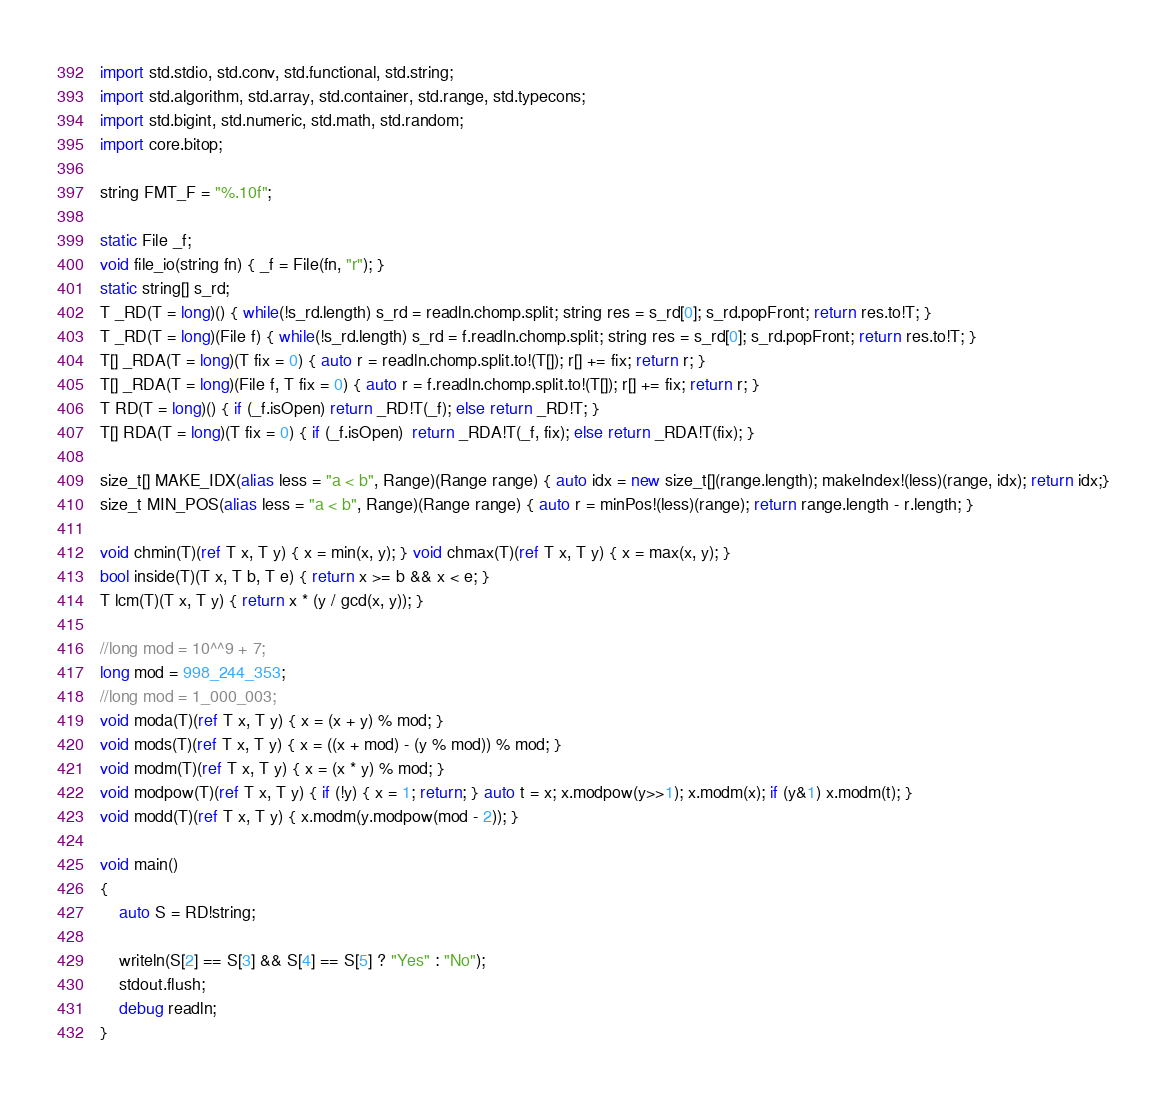Convert code to text. <code><loc_0><loc_0><loc_500><loc_500><_D_>import std.stdio, std.conv, std.functional, std.string;
import std.algorithm, std.array, std.container, std.range, std.typecons;
import std.bigint, std.numeric, std.math, std.random;
import core.bitop;

string FMT_F = "%.10f";

static File _f;
void file_io(string fn) { _f = File(fn, "r"); }
static string[] s_rd;
T _RD(T = long)() { while(!s_rd.length) s_rd = readln.chomp.split; string res = s_rd[0]; s_rd.popFront; return res.to!T; }
T _RD(T = long)(File f) { while(!s_rd.length) s_rd = f.readln.chomp.split; string res = s_rd[0]; s_rd.popFront; return res.to!T; }
T[] _RDA(T = long)(T fix = 0) { auto r = readln.chomp.split.to!(T[]); r[] += fix; return r; }
T[] _RDA(T = long)(File f, T fix = 0) { auto r = f.readln.chomp.split.to!(T[]); r[] += fix; return r; }
T RD(T = long)() { if (_f.isOpen) return _RD!T(_f); else return _RD!T; }
T[] RDA(T = long)(T fix = 0) { if (_f.isOpen)  return _RDA!T(_f, fix); else return _RDA!T(fix); }

size_t[] MAKE_IDX(alias less = "a < b", Range)(Range range) { auto idx = new size_t[](range.length); makeIndex!(less)(range, idx); return idx;}
size_t MIN_POS(alias less = "a < b", Range)(Range range) { auto r = minPos!(less)(range); return range.length - r.length; }

void chmin(T)(ref T x, T y) { x = min(x, y); } void chmax(T)(ref T x, T y) { x = max(x, y); }
bool inside(T)(T x, T b, T e) { return x >= b && x < e; }
T lcm(T)(T x, T y) { return x * (y / gcd(x, y)); }

//long mod = 10^^9 + 7;
long mod = 998_244_353;
//long mod = 1_000_003;
void moda(T)(ref T x, T y) { x = (x + y) % mod; }
void mods(T)(ref T x, T y) { x = ((x + mod) - (y % mod)) % mod; }
void modm(T)(ref T x, T y) { x = (x * y) % mod; }
void modpow(T)(ref T x, T y) { if (!y) { x = 1; return; } auto t = x; x.modpow(y>>1); x.modm(x); if (y&1) x.modm(t); }
void modd(T)(ref T x, T y) { x.modm(y.modpow(mod - 2)); }

void main()
{
	auto S = RD!string;

	writeln(S[2] == S[3] && S[4] == S[5] ? "Yes" : "No");
	stdout.flush;
	debug readln;
}</code> 